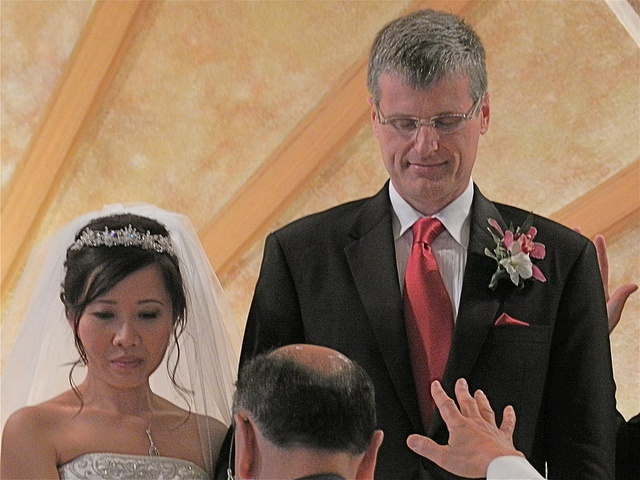Describe the objects in this image and their specific colors. I can see people in tan, black, brown, gray, and maroon tones, people in tan, brown, black, and darkgray tones, people in tan, black, brown, gray, and maroon tones, and tie in tan, maroon, black, and brown tones in this image. 